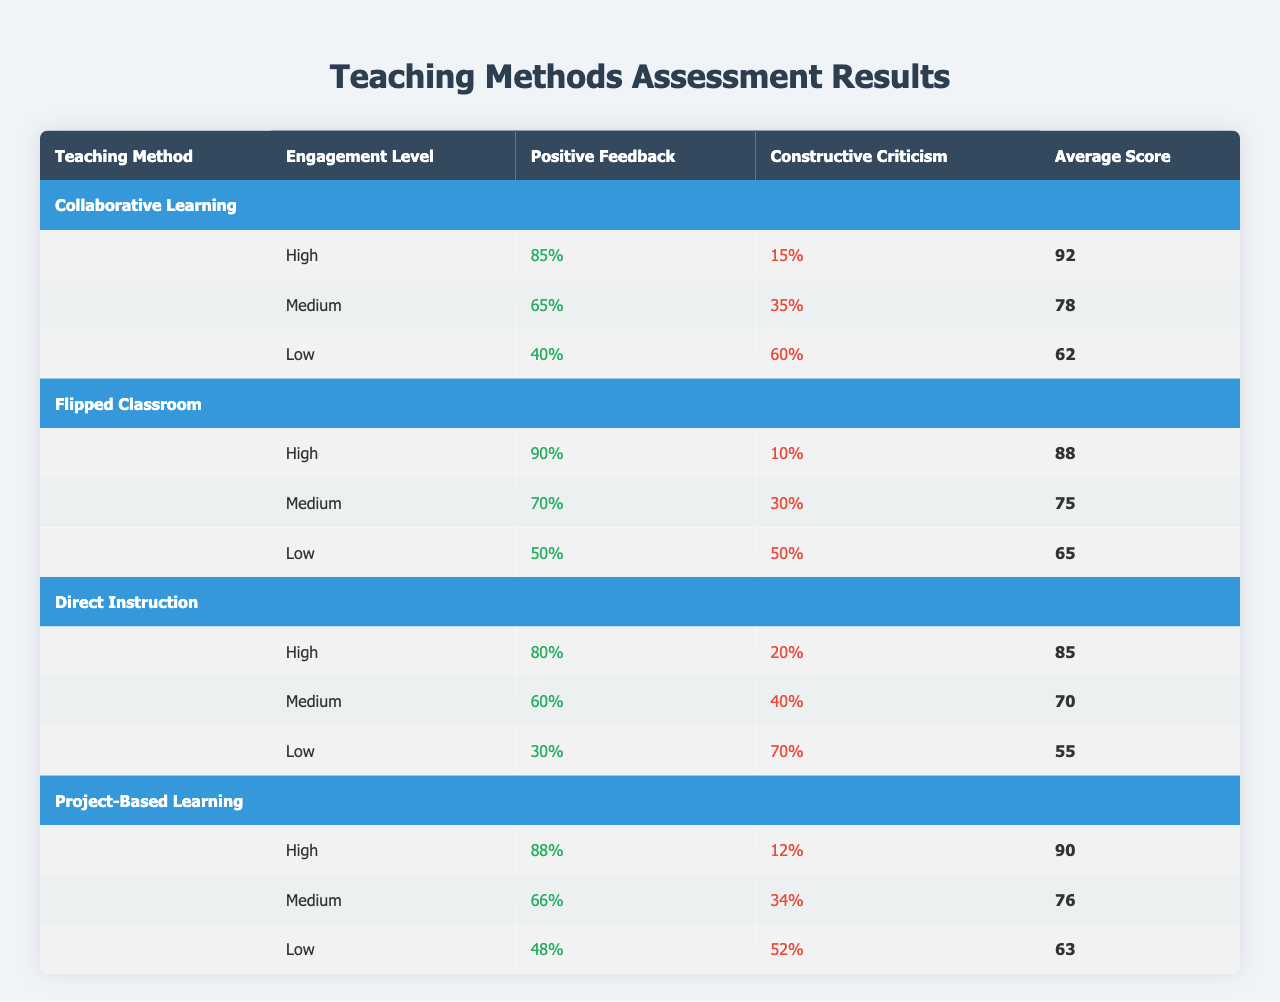What is the average score for the teaching method "Flipped Classroom" at a High engagement level? From the table, we can find the average score for "Flipped Classroom" at the "High" engagement level listed as 88.
Answer: 88 How many positive comments were received for "Collaborative Learning" at the Medium engagement level? The table shows that "Collaborative Learning" received 65% positive comments at the "Medium" engagement level.
Answer: 65% What is the total number of constructive criticism comments for "Project-Based Learning" across all engagement levels? To find the total constructive criticism for "Project-Based Learning", we add the values: 12% (High) + 34% (Medium) + 52% (Low) = 98%.
Answer: 98% Is the average score for "Direct Instruction" higher at the High or Medium engagement level? The average score for "Direct Instruction" is 85 at High and 70 at Medium. Since 85 is greater than 70, the average score is higher at the High level.
Answer: Yes What is the difference in positive feedback percentage between the High engagement level and the Low engagement level for "Flipped Classroom"? From the table, at High engagement, the positive feedback is 90% and at Low engagement, it is 50%. The difference is 90% - 50% = 40%.
Answer: 40% Which teaching method achieved the highest average score at any engagement level? Looking at the average scores for each method, "Collaborative Learning" has the highest score of 92 at High engagement.
Answer: Collaborative Learning What is the engagement level with the lowest percentage of positive feedback for "Direct Instruction"? Reviewing the table, the Low engagement level for "Direct Instruction" has the lowest percentage of positive feedback at 30%.
Answer: Low Which method has the highest positive feedback percentage at a Medium engagement level? For Medium engagement, "Collaborative Learning" has the highest positive feedback at 65% compared to the others.
Answer: Collaborative Learning 